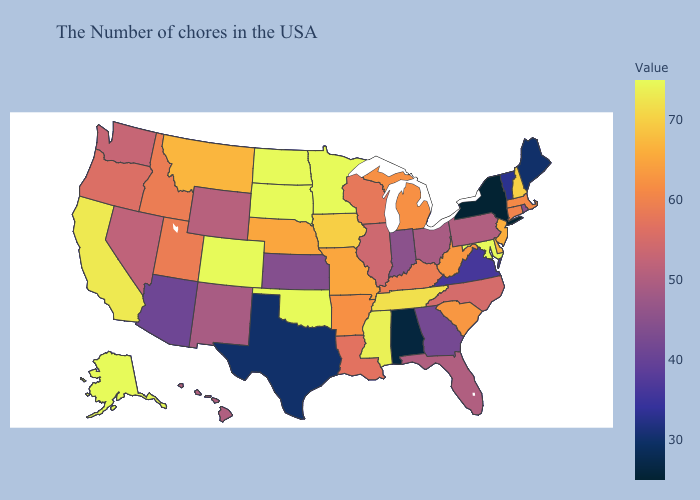Does Massachusetts have the lowest value in the Northeast?
Be succinct. No. Which states hav the highest value in the Northeast?
Be succinct. New Hampshire. Does New York have the lowest value in the USA?
Concise answer only. Yes. Which states have the lowest value in the USA?
Quick response, please. New York. Among the states that border Montana , does Idaho have the lowest value?
Quick response, please. No. Does Louisiana have a higher value than Kansas?
Write a very short answer. Yes. Which states hav the highest value in the West?
Give a very brief answer. Colorado, Alaska. 